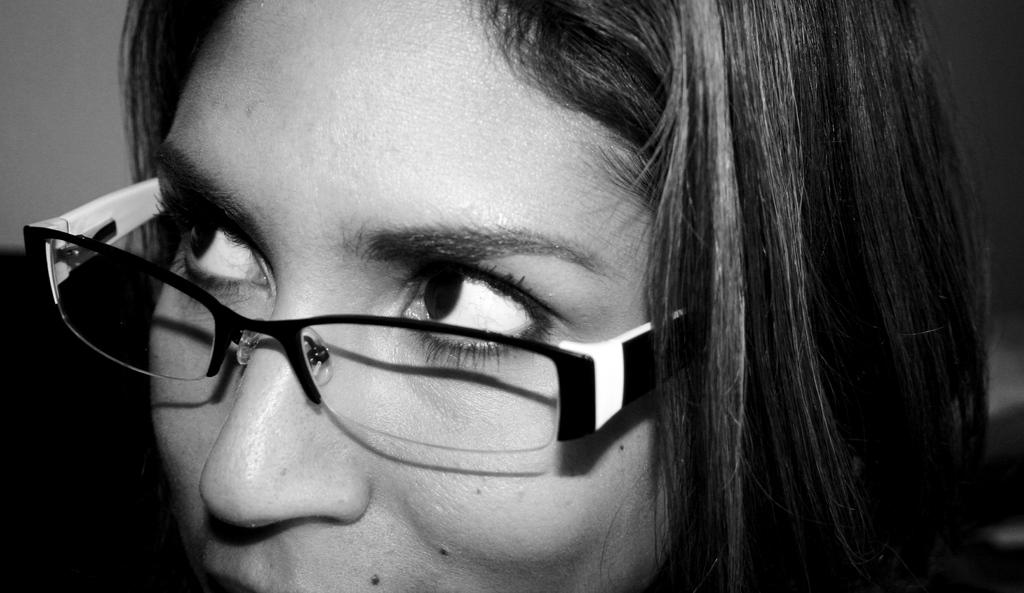What is the color scheme of the image? The image is black and white. Who is present in the image? There is a woman in the image. What accessory is the woman wearing? The woman is wearing spectacles. Can you describe the background of the image? The background behind the woman is blurred. How many chairs are visible in the image? There are no chairs present in the image. What is the woman's income in the image? There is no information about the woman's income in the image. 